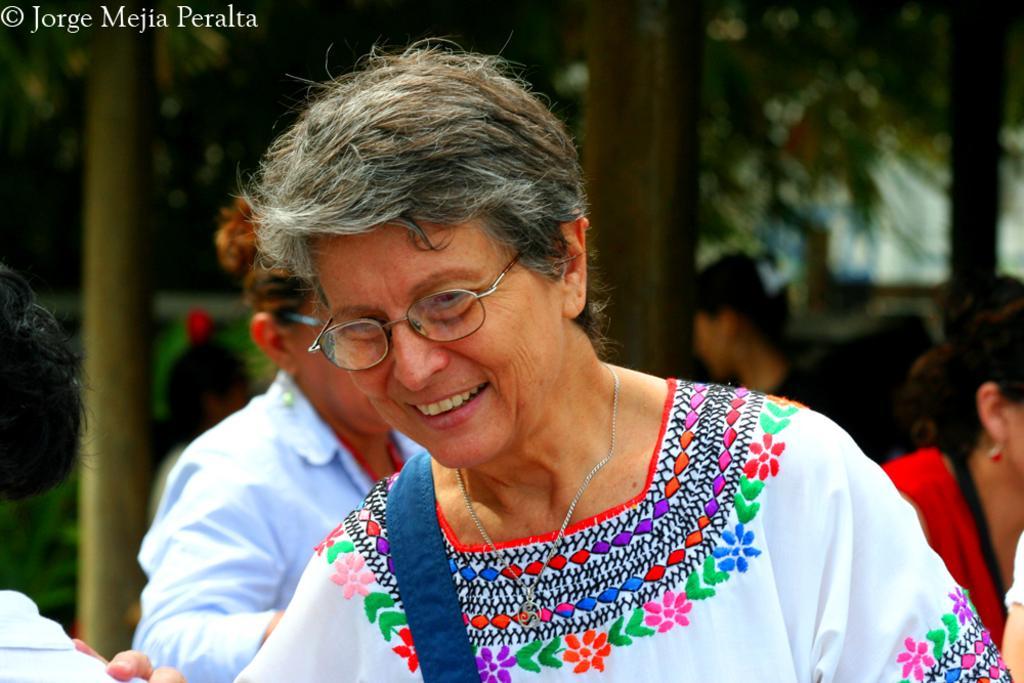Can you describe this image briefly? In the image in the center we can see few people were standing. And the middle woman,she is smiling. In the background we can see few people standing,glass building,pole and few other objects. 